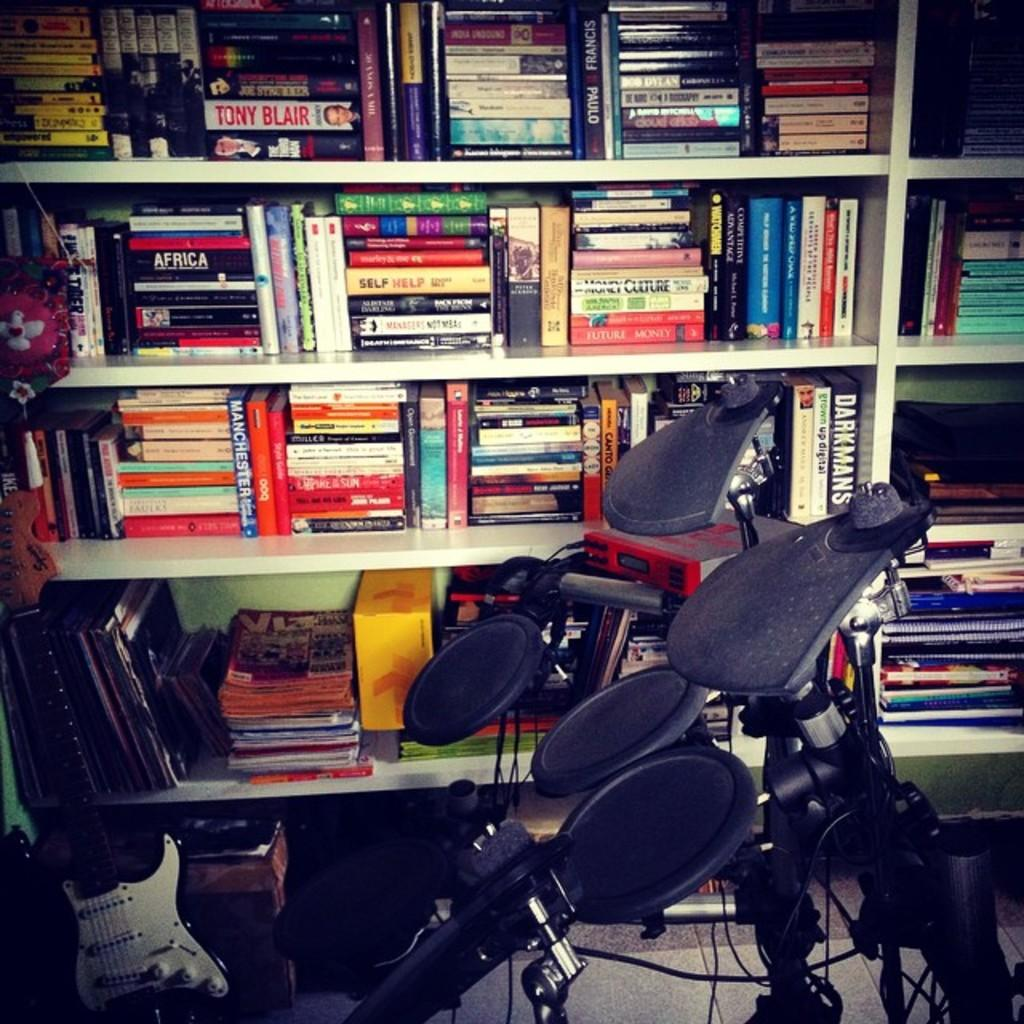<image>
Render a clear and concise summary of the photo. Book shelves include the title Self Help on a yellow book and many others. 